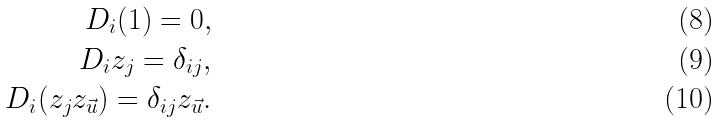<formula> <loc_0><loc_0><loc_500><loc_500>D _ { i } ( 1 ) = 0 , \\ D _ { i } z _ { j } = \delta _ { i j } , \\ D _ { i } ( z _ { j } z _ { \vec { u } } ) = \delta _ { i j } z _ { \vec { u } } .</formula> 